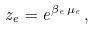<formula> <loc_0><loc_0><loc_500><loc_500>z _ { e } = e ^ { \beta _ { e } \, \mu _ { e } } \, ,</formula> 